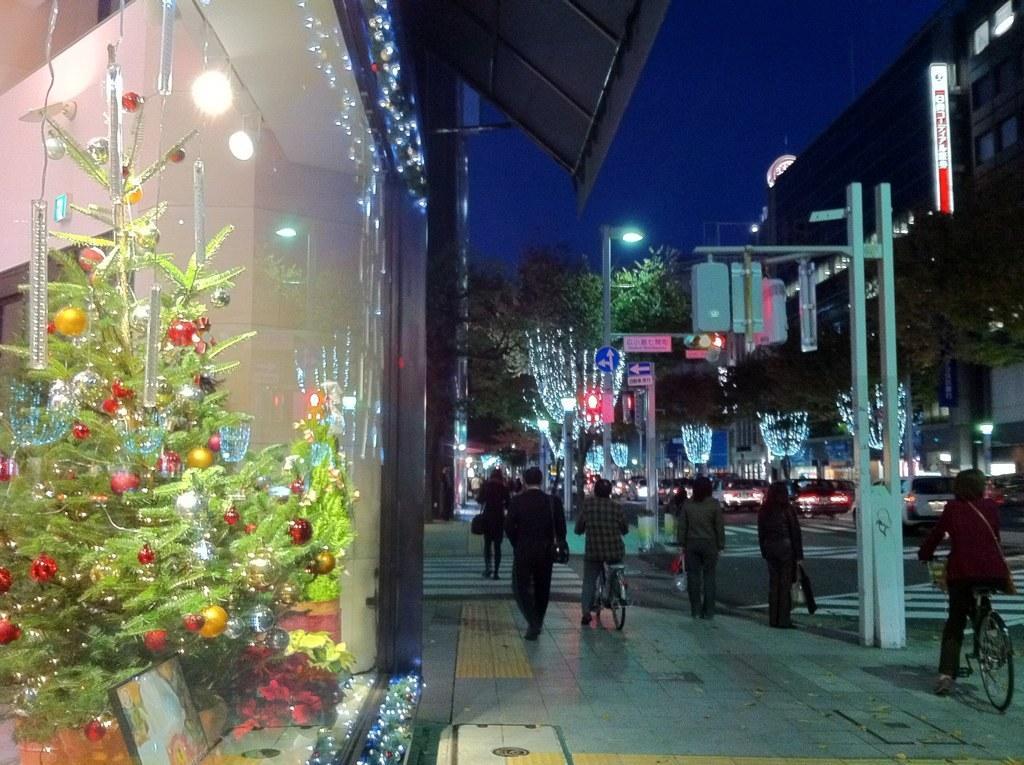In one or two sentences, can you explain what this image depicts? In this picture we can see vehicles on the road, sign boards, poles, buildings with windows, sun shades, trees and a group of people where two persons are riding bicycles and in the background we can see the sky. 